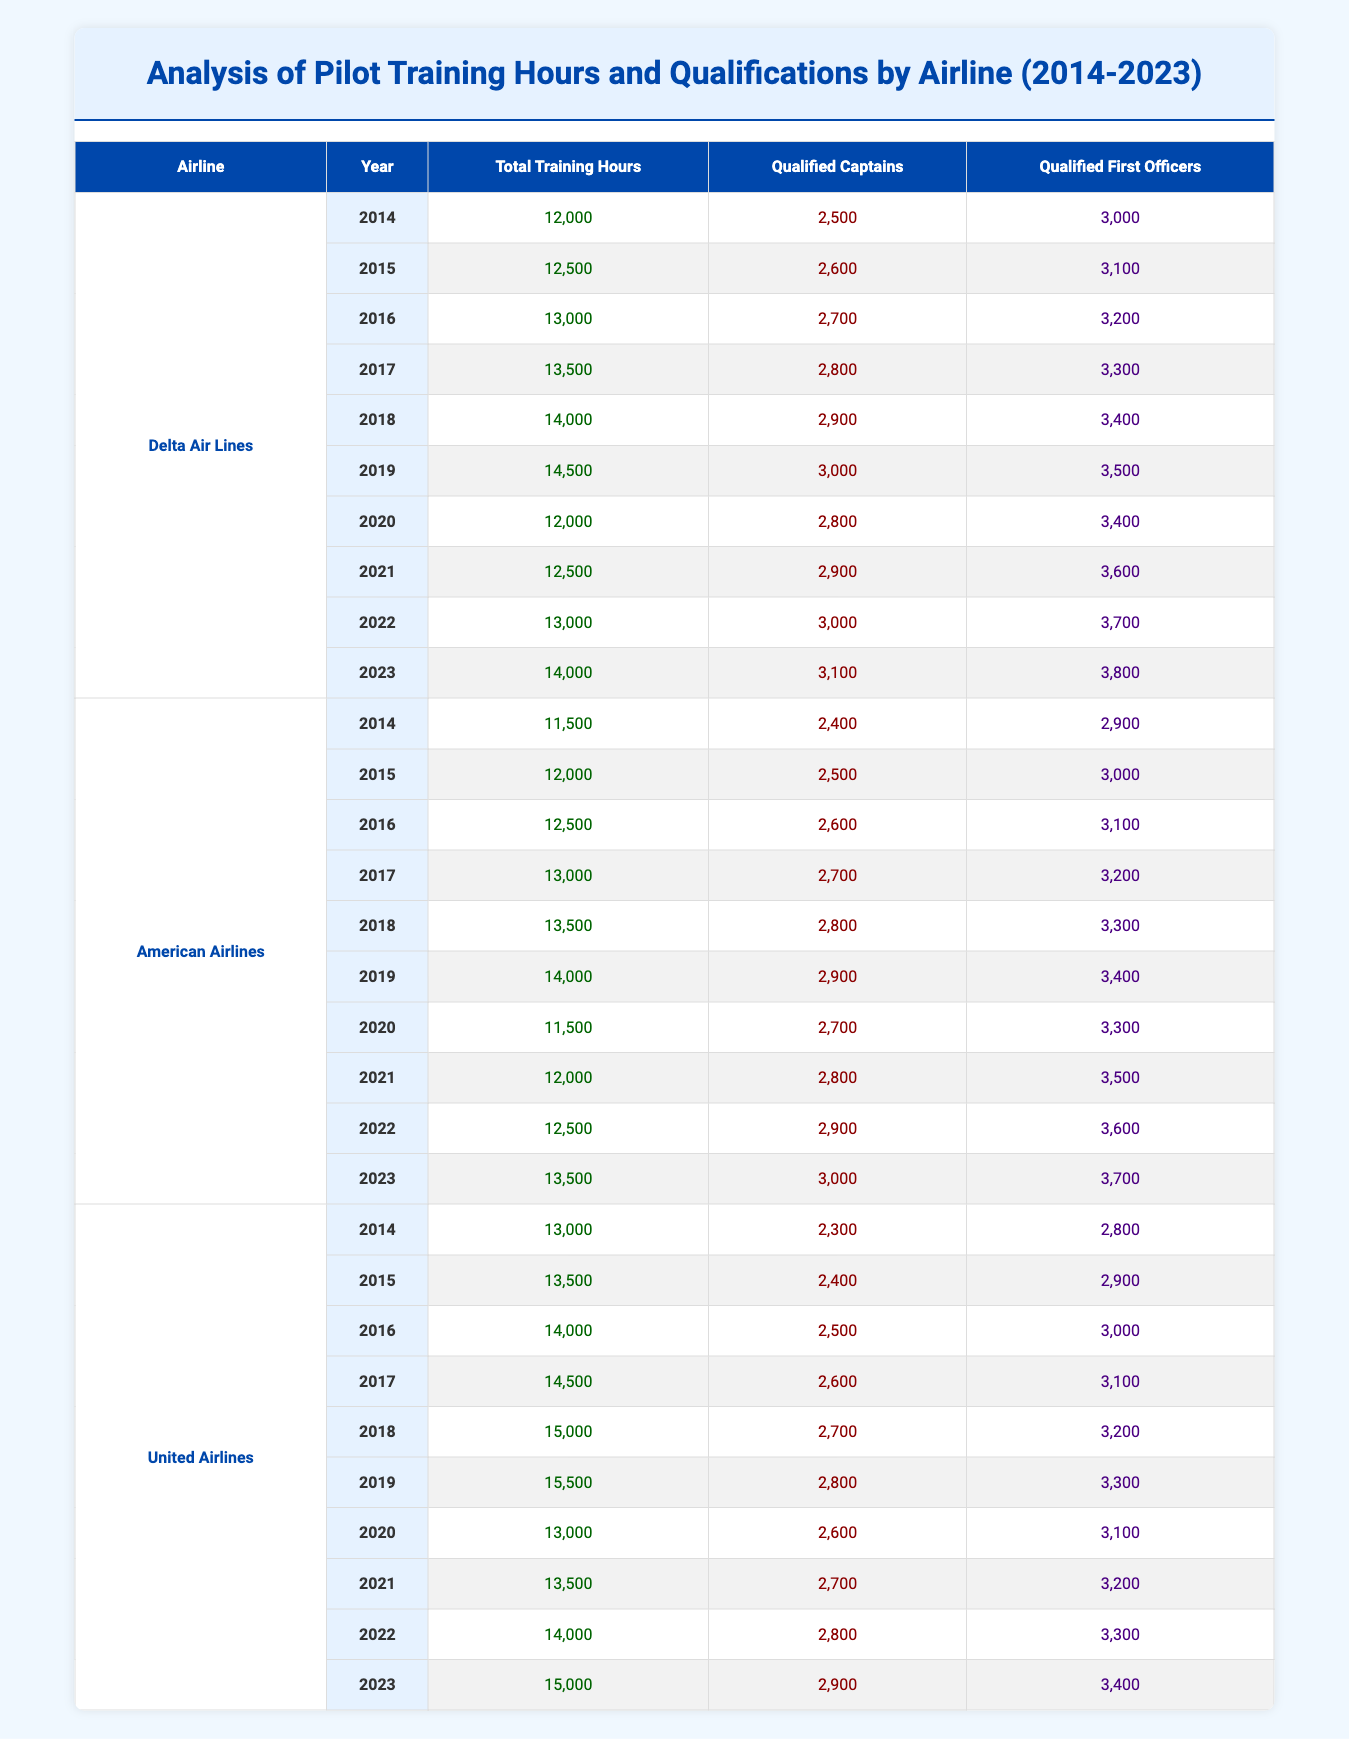What was the total training hours for Delta Air Lines in 2019? The table shows that the total training hours for Delta Air Lines in 2019 is explicitly listed under that year, which is 14,500.
Answer: 14,500 How many qualified captains did American Airlines have in 2021? From the table, we can find the year 2021 for American Airlines, and it states that there were 2,800 qualified captains that year.
Answer: 2,800 What was the trend of total training hours for United Airlines from 2014 to 2023? By examining the training hours for each year listed for United Airlines, we can summarize the total training hours steadily increased from 13,000 in 2014 to 15,000 in 2023, except for some fluctuations in between.
Answer: Steadily increased How many more qualified first officers did Delta Air Lines have than American Airlines in 2022? In 2022, Delta Air Lines had 3,700 qualified first officers while American Airlines had 3,600. Thus, the difference can be found by subtracting 3,600 from 3,700, giving us a total of 100 more qualified first officers for Delta.
Answer: 100 Was there any year from 2014 to 2023 when American Airlines had higher total training hours than Delta Air Lines? By reviewing the data, American Airlines had lesser total training hours than Delta Air Lines every year from 2014 to 2023, indicating that it is false that there was any year when American Airlines was higher.
Answer: No What was the average number of qualified captains for United Airlines over the years 2014 to 2023? To find the average, we first sum the qualified captains for United Airlines from each year, which are 2,300 + 2,400 + 2,500 + 2,600 + 2,700 + 2,800 + 2,600 + 2,700 + 2,800 + 2,900 = 27,800. Then, dividing by the number of years (10) gives an average of 2,780.
Answer: 2,780 In which year did Delta Air Lines see the highest increase in qualified first officers compared to the previous year? To find this, we compare the qualified first officers year-to-year: 3,000 (2014) to 3,000 (2015) = 0; 3,100 (2015) to 3,200 (2016) = 100; 3,200 to 3,300 = 100; 3,300 to 3,400 = 100; the highest increase was from 3,400 to 3,500 at 100; however, since all years have consistent increases, we see no major peak. Thus, the maximum was consistently at 100.
Answer: 100 Is it true that in 2020 all airlines had a decrease in total training hours compared to the previous year? Examining the data reveals that Delta Air Lines' total training hours dropped from 14,500 in 2019 to 12,000 in 2020, and American Airlines dropped from 14,000 to 11,500; however, United Airlines remained the same as prior, showing it's false that all airlines had a decrease.
Answer: No 